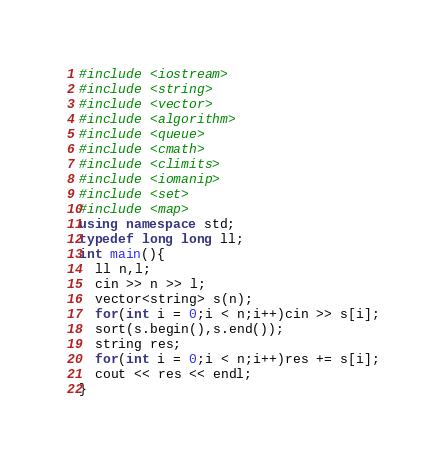<code> <loc_0><loc_0><loc_500><loc_500><_C++_>#include <iostream>
#include <string>
#include <vector>
#include <algorithm>
#include <queue>
#include <cmath>
#include <climits>
#include <iomanip>
#include <set>
#include <map>
using namespace std;
typedef long long ll;
int main(){
  ll n,l;
  cin >> n >> l;
  vector<string> s(n);
  for(int i = 0;i < n;i++)cin >> s[i];
  sort(s.begin(),s.end());
  string res;
  for(int i = 0;i < n;i++)res += s[i];
  cout << res << endl;
}</code> 